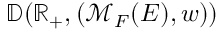Convert formula to latex. <formula><loc_0><loc_0><loc_500><loc_500>\mathbb { D } ( \mathbb { R } _ { + } , ( \mathcal { M } _ { F } ( E ) , w ) )</formula> 